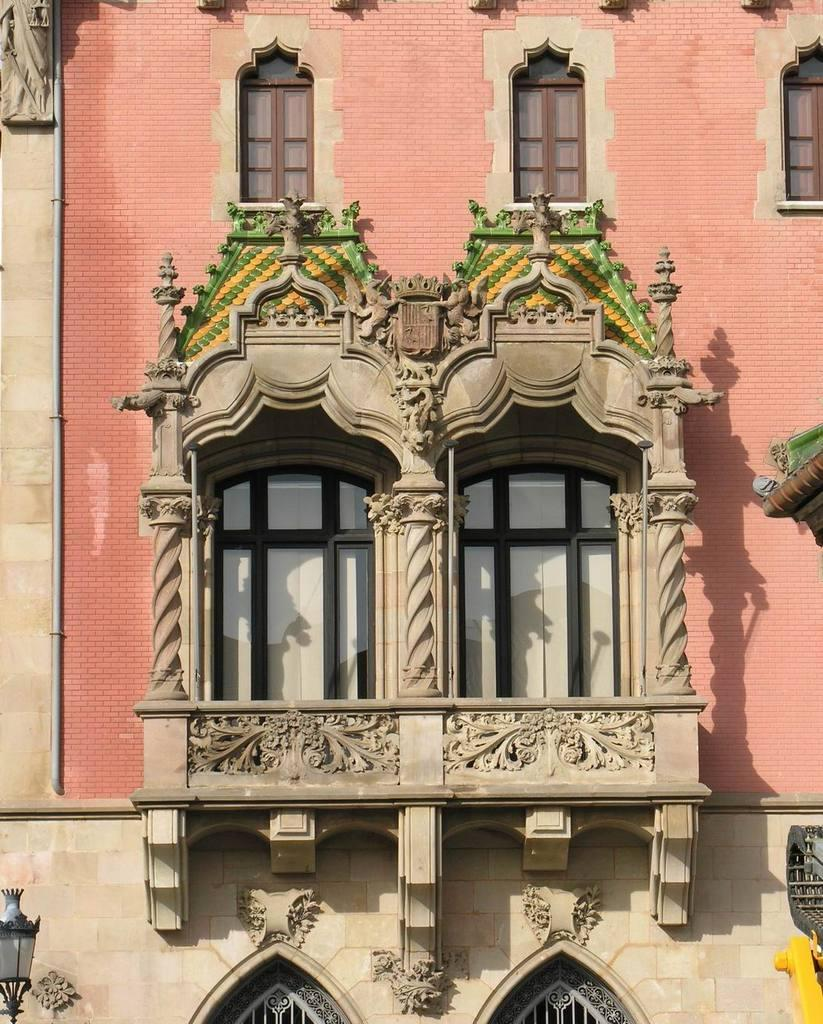What is the main structure in the image? There is a building in the image. What feature can be seen on the building? The building has windows. What additional object is visible at the bottom left of the image? There is a street lamp at the bottom left of the image. Where is the swing located in the image? There is no swing present in the image. What part of the brain can be seen in the image? There is no brain present in the image. 